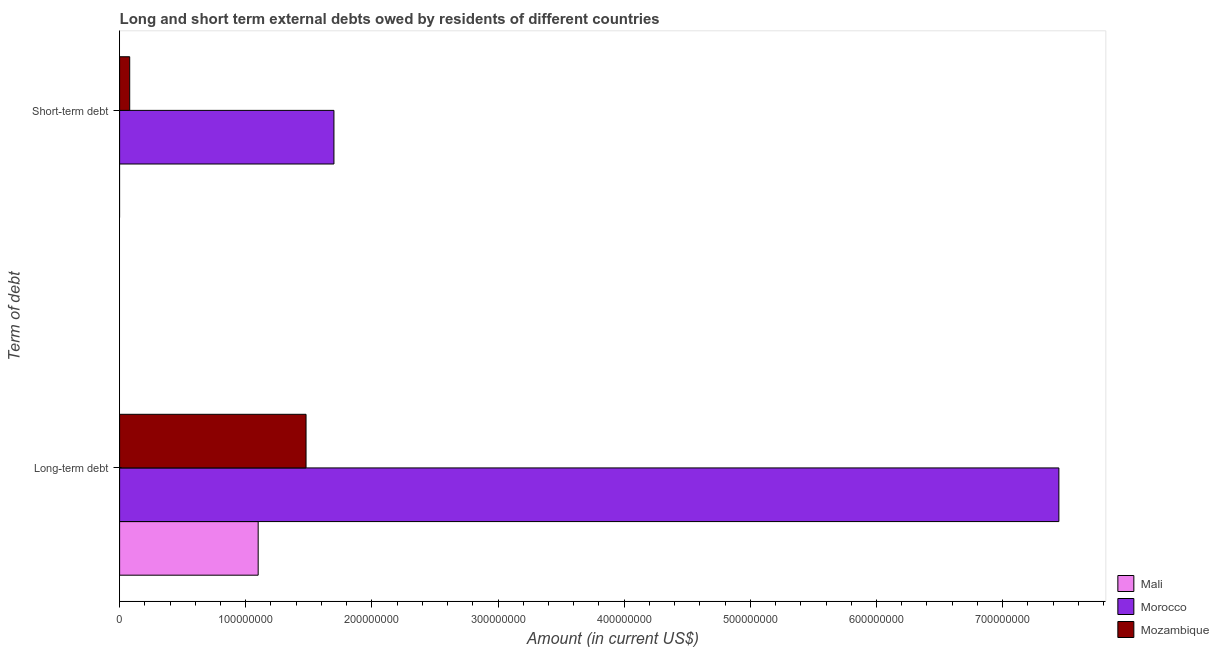How many different coloured bars are there?
Keep it short and to the point. 3. How many groups of bars are there?
Your response must be concise. 2. Are the number of bars per tick equal to the number of legend labels?
Keep it short and to the point. No. What is the label of the 1st group of bars from the top?
Ensure brevity in your answer.  Short-term debt. What is the short-term debts owed by residents in Mali?
Your answer should be very brief. 0. Across all countries, what is the maximum long-term debts owed by residents?
Your answer should be very brief. 7.45e+08. Across all countries, what is the minimum long-term debts owed by residents?
Ensure brevity in your answer.  1.10e+08. In which country was the long-term debts owed by residents maximum?
Make the answer very short. Morocco. What is the total long-term debts owed by residents in the graph?
Make the answer very short. 1.00e+09. What is the difference between the long-term debts owed by residents in Mozambique and that in Mali?
Ensure brevity in your answer.  3.79e+07. What is the difference between the short-term debts owed by residents in Mali and the long-term debts owed by residents in Morocco?
Make the answer very short. -7.45e+08. What is the average short-term debts owed by residents per country?
Give a very brief answer. 5.93e+07. What is the difference between the long-term debts owed by residents and short-term debts owed by residents in Morocco?
Provide a short and direct response. 5.75e+08. What is the ratio of the long-term debts owed by residents in Mozambique to that in Mali?
Provide a short and direct response. 1.35. Is the long-term debts owed by residents in Morocco less than that in Mali?
Your answer should be compact. No. How many bars are there?
Ensure brevity in your answer.  5. How many countries are there in the graph?
Your answer should be compact. 3. Are the values on the major ticks of X-axis written in scientific E-notation?
Provide a succinct answer. No. Does the graph contain any zero values?
Provide a succinct answer. Yes. What is the title of the graph?
Offer a terse response. Long and short term external debts owed by residents of different countries. What is the label or title of the X-axis?
Offer a very short reply. Amount (in current US$). What is the label or title of the Y-axis?
Provide a short and direct response. Term of debt. What is the Amount (in current US$) in Mali in Long-term debt?
Offer a terse response. 1.10e+08. What is the Amount (in current US$) of Morocco in Long-term debt?
Give a very brief answer. 7.45e+08. What is the Amount (in current US$) of Mozambique in Long-term debt?
Keep it short and to the point. 1.48e+08. What is the Amount (in current US$) in Morocco in Short-term debt?
Your answer should be very brief. 1.70e+08. What is the Amount (in current US$) of Mozambique in Short-term debt?
Provide a succinct answer. 8.00e+06. Across all Term of debt, what is the maximum Amount (in current US$) in Mali?
Ensure brevity in your answer.  1.10e+08. Across all Term of debt, what is the maximum Amount (in current US$) in Morocco?
Give a very brief answer. 7.45e+08. Across all Term of debt, what is the maximum Amount (in current US$) in Mozambique?
Provide a succinct answer. 1.48e+08. Across all Term of debt, what is the minimum Amount (in current US$) of Morocco?
Offer a very short reply. 1.70e+08. What is the total Amount (in current US$) of Mali in the graph?
Give a very brief answer. 1.10e+08. What is the total Amount (in current US$) of Morocco in the graph?
Your response must be concise. 9.14e+08. What is the total Amount (in current US$) in Mozambique in the graph?
Make the answer very short. 1.56e+08. What is the difference between the Amount (in current US$) in Morocco in Long-term debt and that in Short-term debt?
Offer a very short reply. 5.75e+08. What is the difference between the Amount (in current US$) of Mozambique in Long-term debt and that in Short-term debt?
Offer a terse response. 1.40e+08. What is the difference between the Amount (in current US$) in Mali in Long-term debt and the Amount (in current US$) in Morocco in Short-term debt?
Offer a very short reply. -6.01e+07. What is the difference between the Amount (in current US$) in Mali in Long-term debt and the Amount (in current US$) in Mozambique in Short-term debt?
Keep it short and to the point. 1.02e+08. What is the difference between the Amount (in current US$) in Morocco in Long-term debt and the Amount (in current US$) in Mozambique in Short-term debt?
Provide a succinct answer. 7.37e+08. What is the average Amount (in current US$) in Mali per Term of debt?
Provide a short and direct response. 5.49e+07. What is the average Amount (in current US$) of Morocco per Term of debt?
Ensure brevity in your answer.  4.57e+08. What is the average Amount (in current US$) of Mozambique per Term of debt?
Give a very brief answer. 7.79e+07. What is the difference between the Amount (in current US$) of Mali and Amount (in current US$) of Morocco in Long-term debt?
Provide a succinct answer. -6.35e+08. What is the difference between the Amount (in current US$) of Mali and Amount (in current US$) of Mozambique in Long-term debt?
Make the answer very short. -3.79e+07. What is the difference between the Amount (in current US$) of Morocco and Amount (in current US$) of Mozambique in Long-term debt?
Make the answer very short. 5.97e+08. What is the difference between the Amount (in current US$) in Morocco and Amount (in current US$) in Mozambique in Short-term debt?
Your answer should be very brief. 1.62e+08. What is the ratio of the Amount (in current US$) of Morocco in Long-term debt to that in Short-term debt?
Your response must be concise. 4.38. What is the ratio of the Amount (in current US$) in Mozambique in Long-term debt to that in Short-term debt?
Your answer should be very brief. 18.47. What is the difference between the highest and the second highest Amount (in current US$) in Morocco?
Ensure brevity in your answer.  5.75e+08. What is the difference between the highest and the second highest Amount (in current US$) in Mozambique?
Your response must be concise. 1.40e+08. What is the difference between the highest and the lowest Amount (in current US$) in Mali?
Ensure brevity in your answer.  1.10e+08. What is the difference between the highest and the lowest Amount (in current US$) in Morocco?
Offer a very short reply. 5.75e+08. What is the difference between the highest and the lowest Amount (in current US$) in Mozambique?
Offer a very short reply. 1.40e+08. 